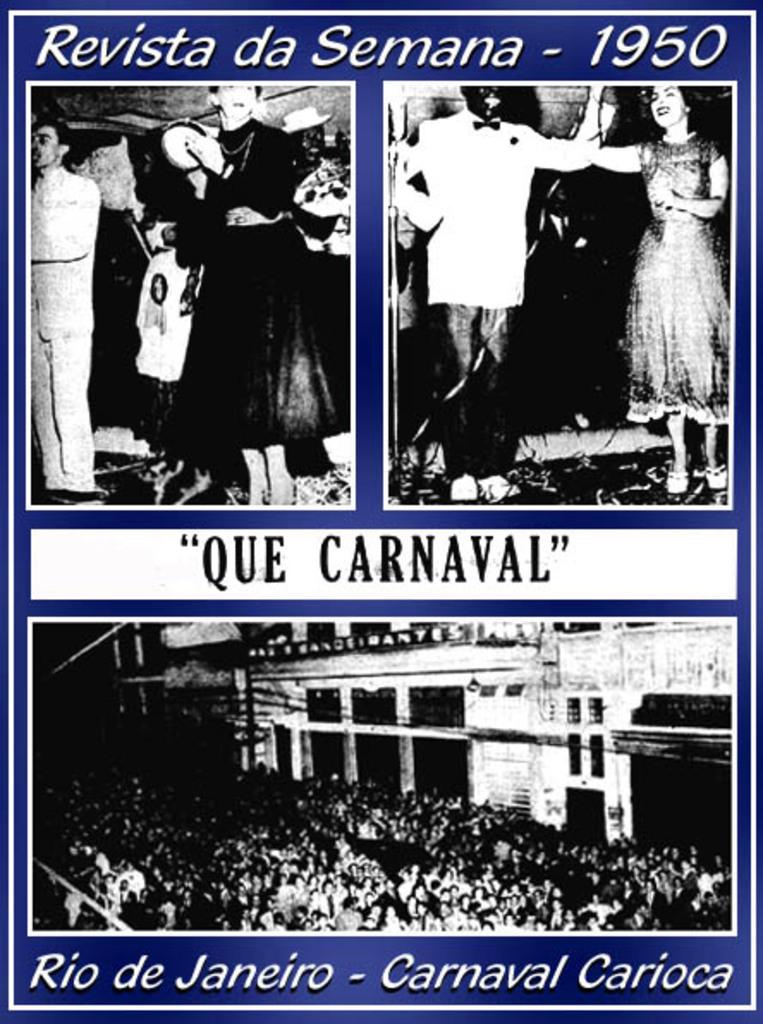What is present in the image? There is a poster in the image. How many images are on the poster? The poster has three images. What can be seen in the images? The images contain persons. What else is on the poster besides the images? There are texts and numbers on the poster. What color is the background of the poster? The background of the poster is violet in color. How many kittens are sitting on the shoulder of the person in the image? There are no kittens present in the image; the images contain persons, but no kittens are visible. 